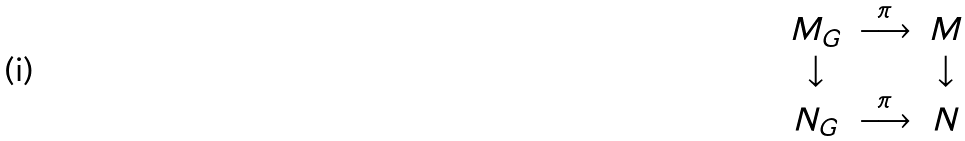Convert formula to latex. <formula><loc_0><loc_0><loc_500><loc_500>\begin{array} { c c c } M _ { G } & \stackrel { \pi } { \longrightarrow } & M \\ \downarrow & & \downarrow \\ N _ { G } & \stackrel { \pi } { \longrightarrow } & N \end{array}</formula> 